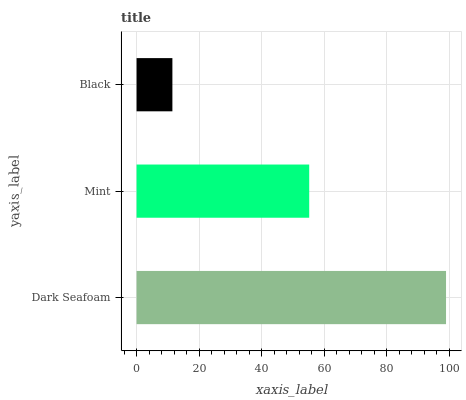Is Black the minimum?
Answer yes or no. Yes. Is Dark Seafoam the maximum?
Answer yes or no. Yes. Is Mint the minimum?
Answer yes or no. No. Is Mint the maximum?
Answer yes or no. No. Is Dark Seafoam greater than Mint?
Answer yes or no. Yes. Is Mint less than Dark Seafoam?
Answer yes or no. Yes. Is Mint greater than Dark Seafoam?
Answer yes or no. No. Is Dark Seafoam less than Mint?
Answer yes or no. No. Is Mint the high median?
Answer yes or no. Yes. Is Mint the low median?
Answer yes or no. Yes. Is Black the high median?
Answer yes or no. No. Is Dark Seafoam the low median?
Answer yes or no. No. 